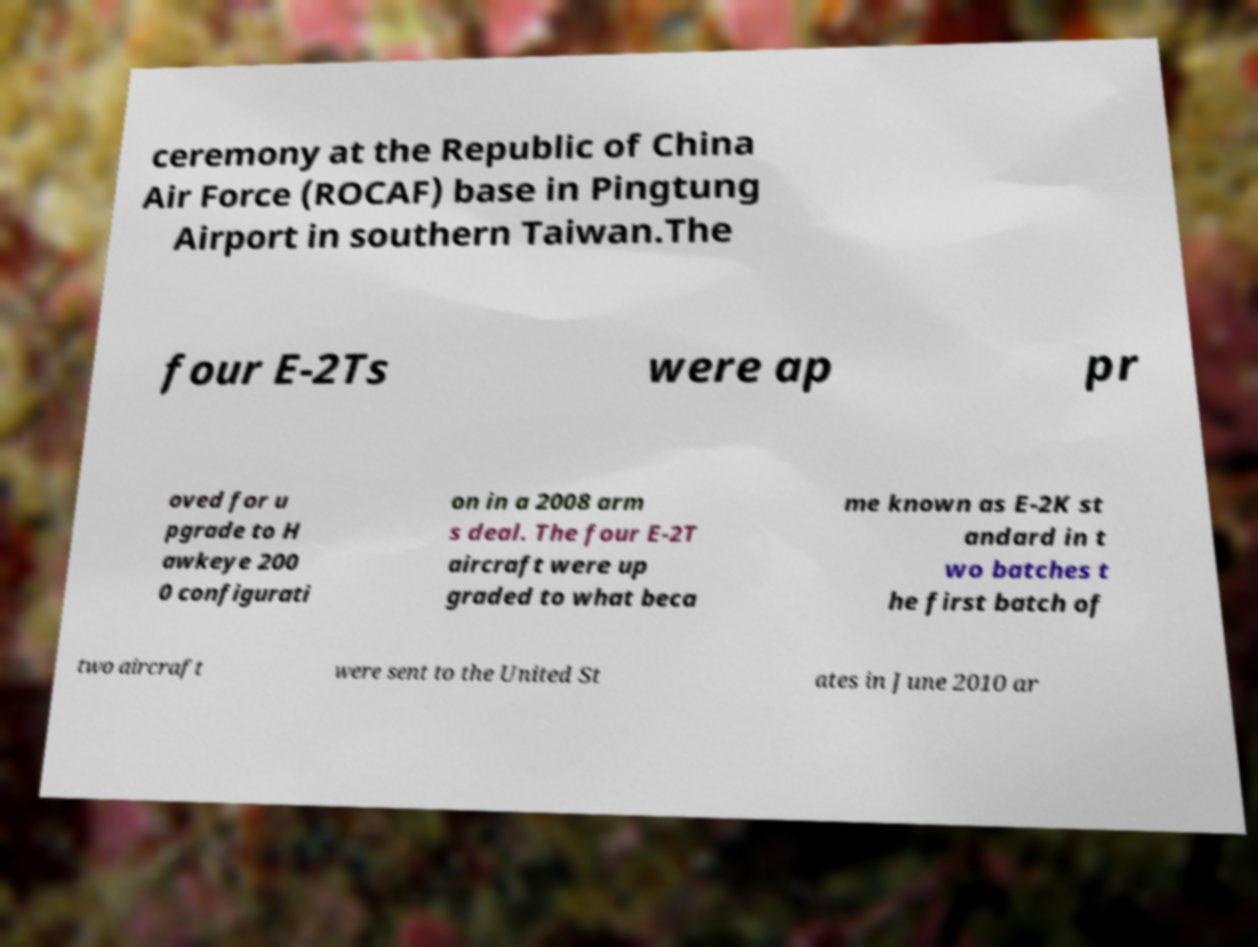Please identify and transcribe the text found in this image. ceremony at the Republic of China Air Force (ROCAF) base in Pingtung Airport in southern Taiwan.The four E-2Ts were ap pr oved for u pgrade to H awkeye 200 0 configurati on in a 2008 arm s deal. The four E-2T aircraft were up graded to what beca me known as E-2K st andard in t wo batches t he first batch of two aircraft were sent to the United St ates in June 2010 ar 